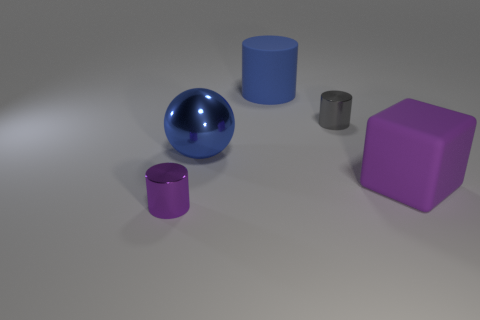Add 1 tiny metallic things. How many objects exist? 6 Subtract all cylinders. How many objects are left? 2 Subtract all big purple rubber cubes. Subtract all purple rubber blocks. How many objects are left? 3 Add 3 large blue matte cylinders. How many large blue matte cylinders are left? 4 Add 3 small gray metal objects. How many small gray metal objects exist? 4 Subtract 0 gray blocks. How many objects are left? 5 